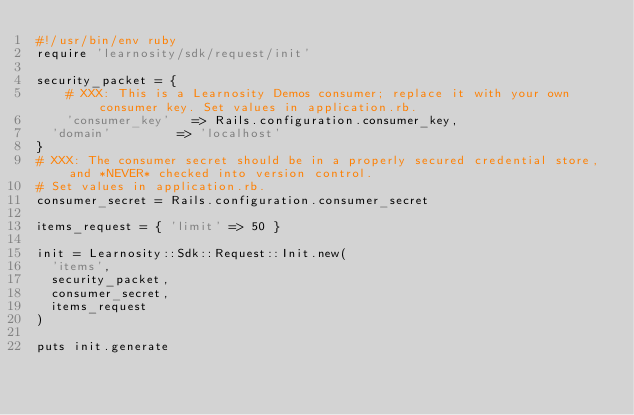<code> <loc_0><loc_0><loc_500><loc_500><_Ruby_>#!/usr/bin/env ruby
require 'learnosity/sdk/request/init'

security_packet = {
    # XXX: This is a Learnosity Demos consumer; replace it with your own consumer key. Set values in application.rb.
    'consumer_key'   => Rails.configuration.consumer_key,
	'domain'         => 'localhost'
}
# XXX: The consumer secret should be in a properly secured credential store, and *NEVER* checked into version control.
# Set values in application.rb.
consumer_secret = Rails.configuration.consumer_secret

items_request = { 'limit' => 50 }

init = Learnosity::Sdk::Request::Init.new(
	'items',
	security_packet,
	consumer_secret,
	items_request
)

puts init.generate
</code> 